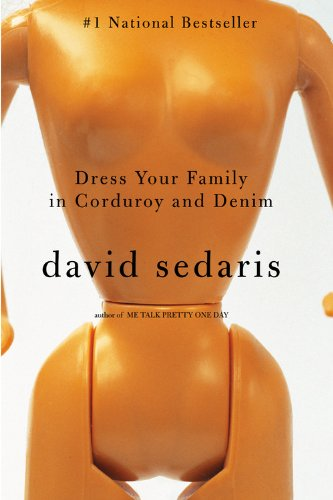What year was 'Dress Your Family in Corduroy and Denim' published? The book 'Dress Your Family in Corduroy and Denim' was published in June 2004. 